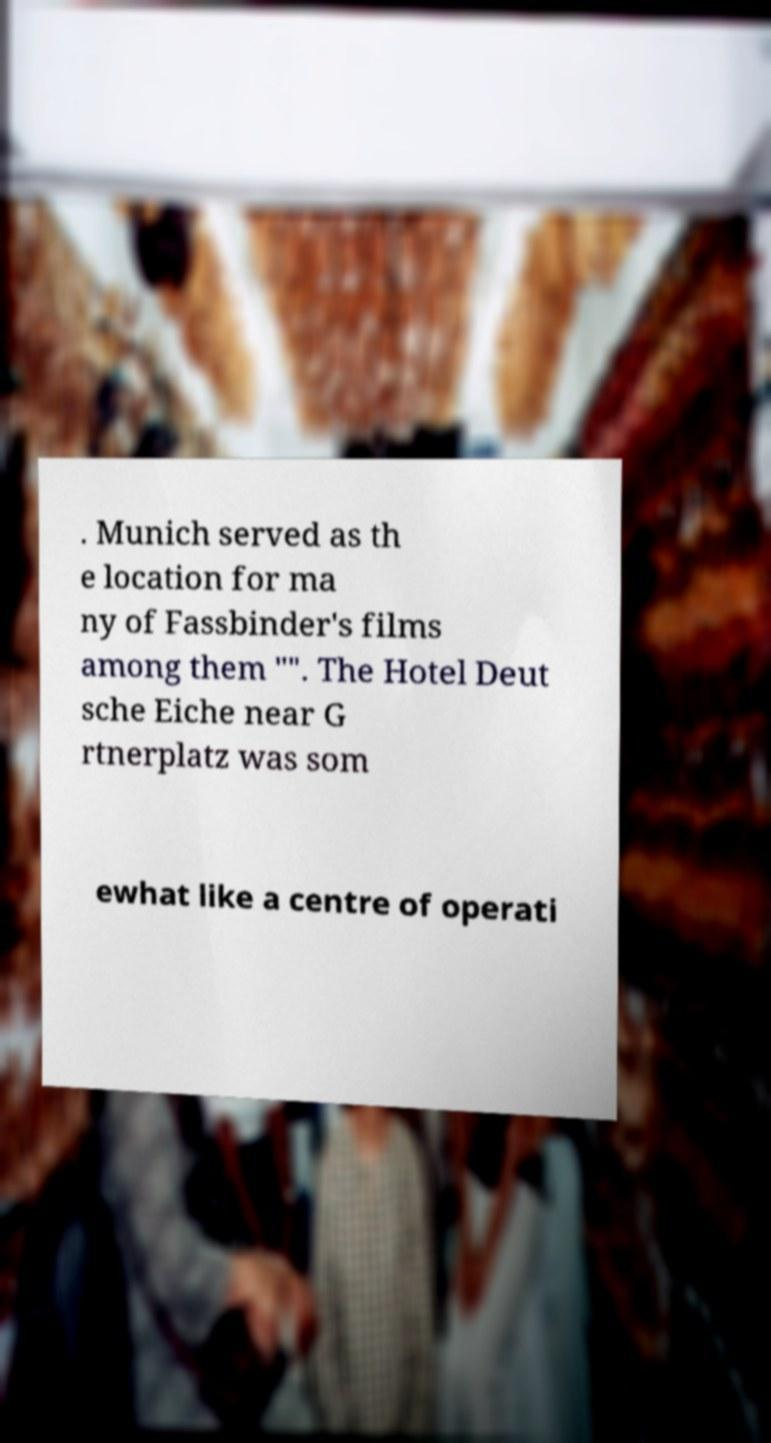Could you extract and type out the text from this image? . Munich served as th e location for ma ny of Fassbinder's films among them "". The Hotel Deut sche Eiche near G rtnerplatz was som ewhat like a centre of operati 